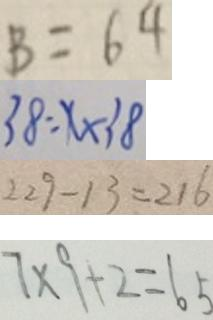<formula> <loc_0><loc_0><loc_500><loc_500>B = 6 4 
 3 8 = x \times 3 8 
 2 2 9 - 1 3 = 2 1 6 
 7 \times 9 + 2 = 6 5</formula> 